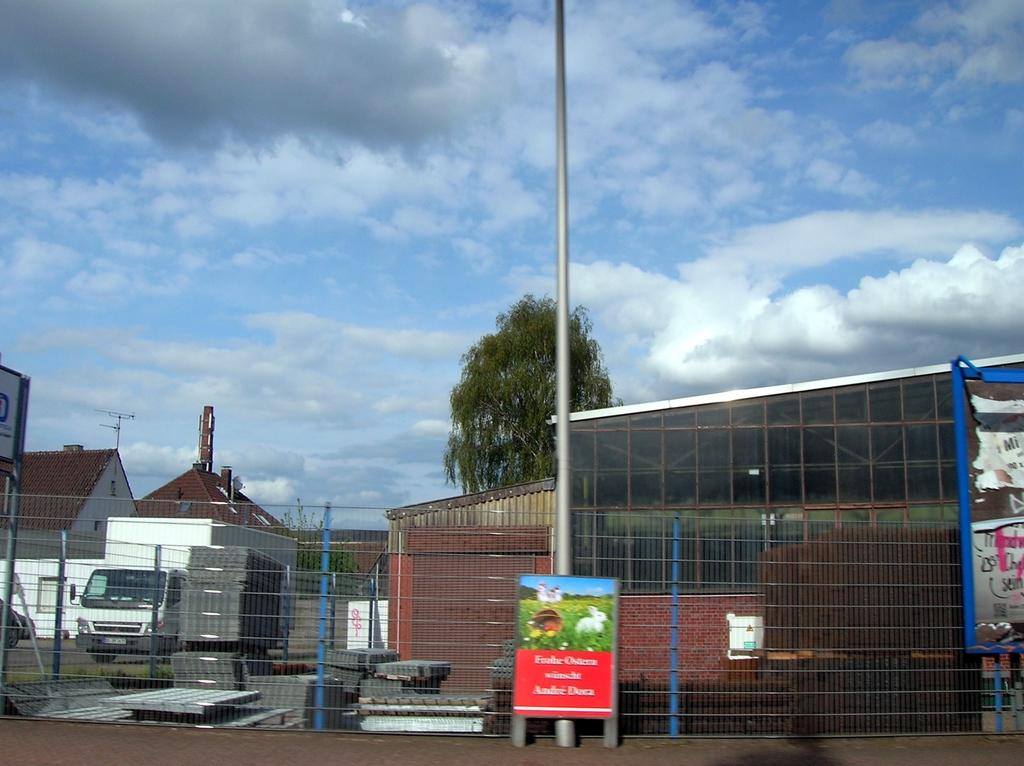What is located in the foreground of the image? There is a poster, a pole, and net fencing in the foreground of the image. What type of structures can be seen in the background? There are shelters and houses in the background. What material are the shelters made of? The shelters appear to be made of metal sheets. What else can be seen in the background? There are trees, a vehicle, and the sky visible in the background. Are there any flowers visible in the image? There are no flowers present in the image. Is there popcorn being served in the shelters in the background? There is no indication of popcorn or any food being served in the image. 